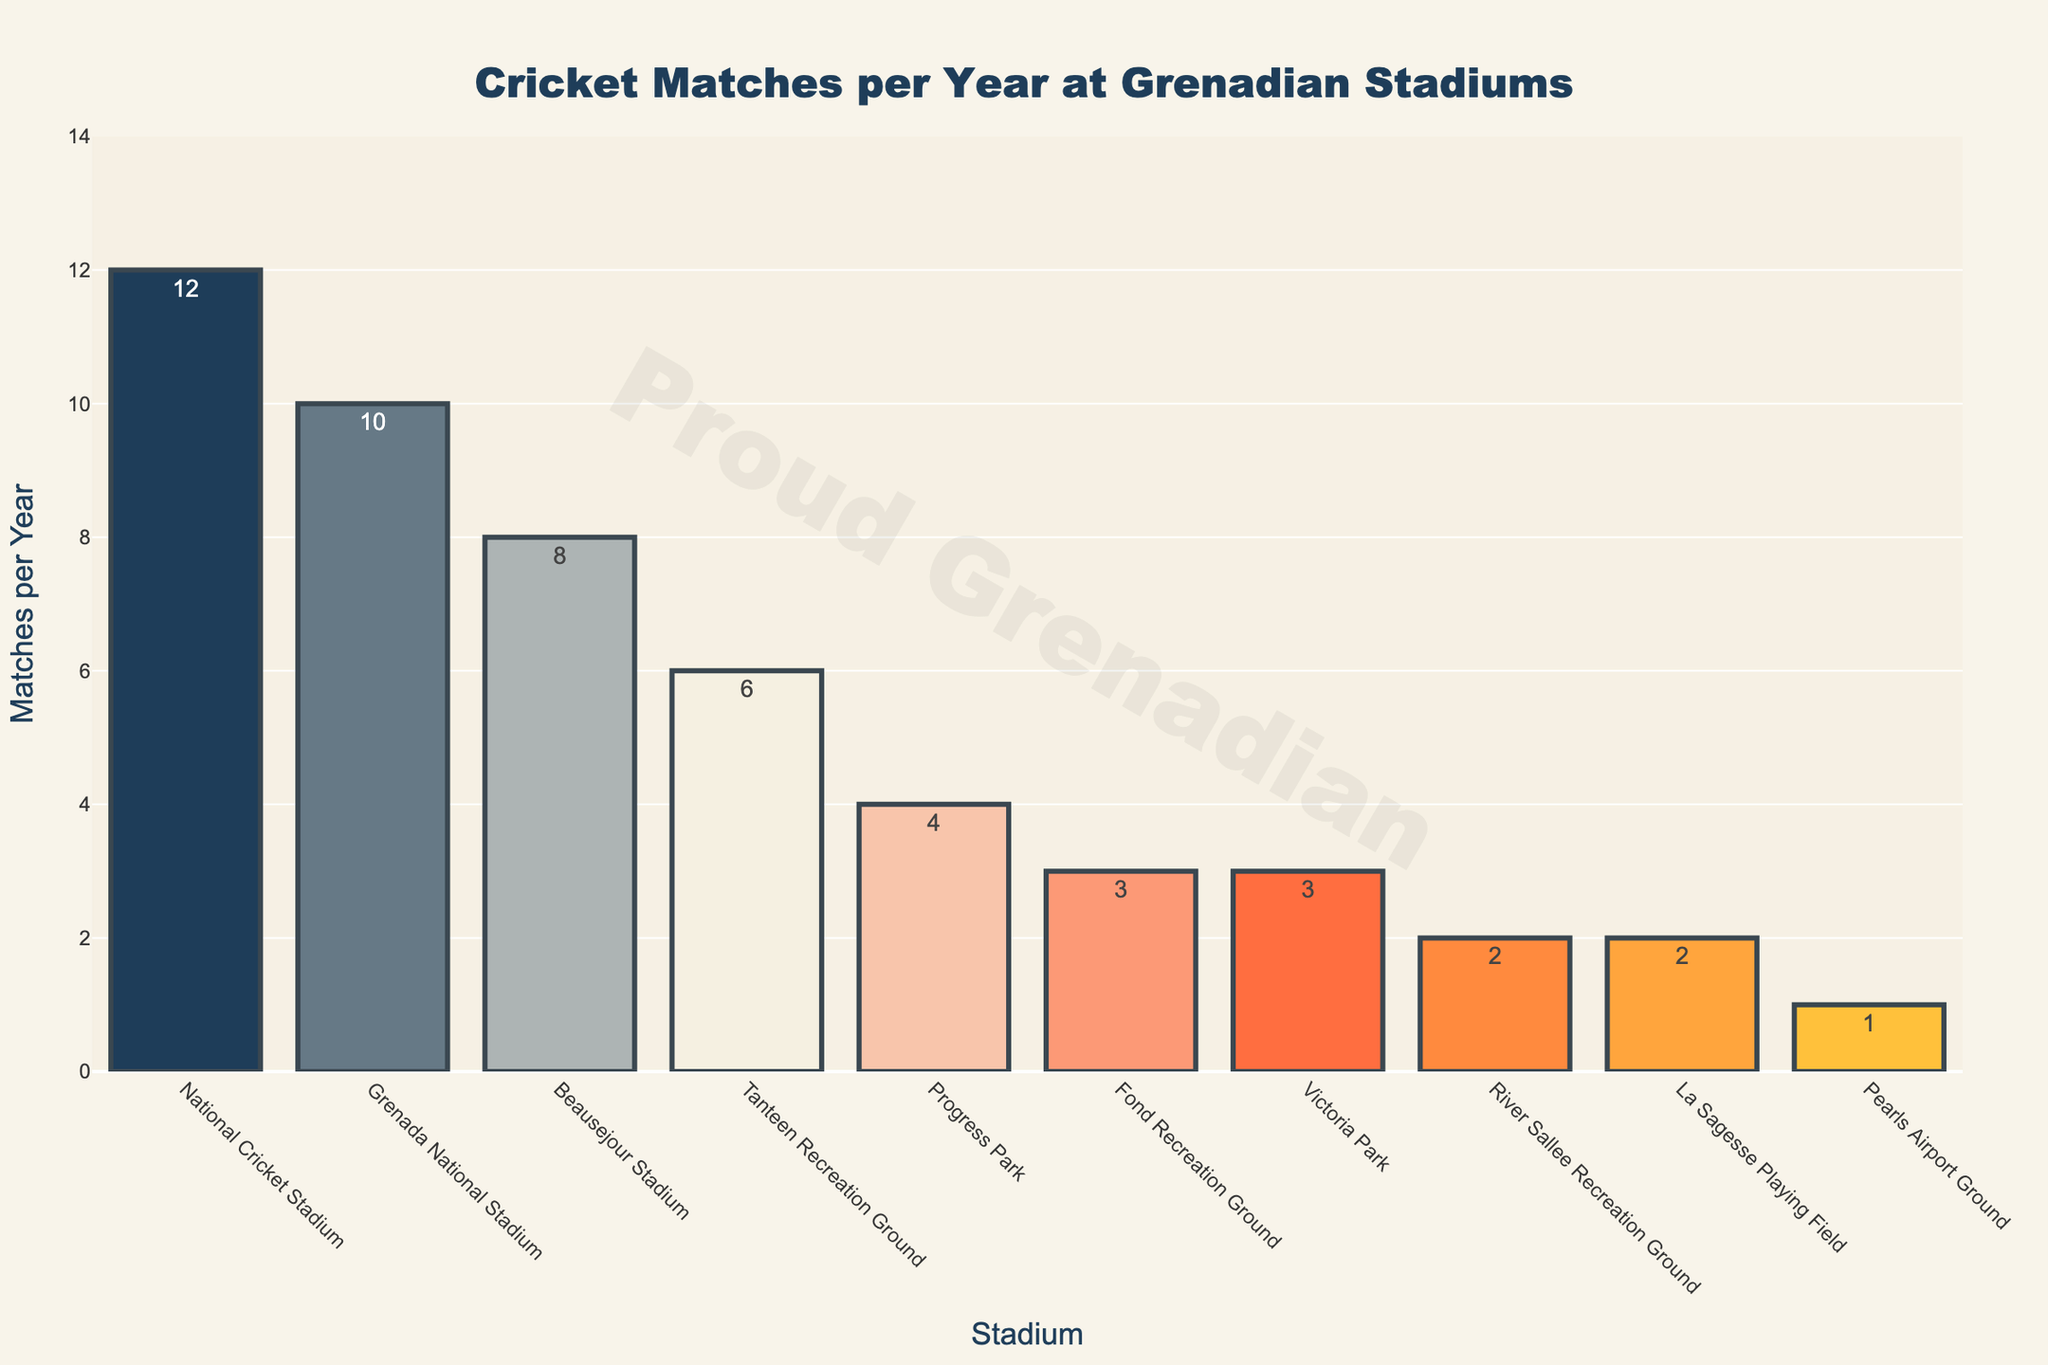Which stadium hosts the most cricket matches per year? The tallest bar in the bar chart represents the stadium with the highest number of matches per year.
Answer: National Cricket Stadium How many matches per year are held at Beausejour Stadium? Look for the bar labeled "Beausejour Stadium" and check the height and the text position displaying the number.
Answer: 8 Which stadium hosts fewer matches per year: Tanteen Recreation Ground or Grenada National Stadium? Compare the heights of the bars labeled "Tanteen Recreation Ground" and "Grenada National Stadium."
Answer: Tanteen Recreation Ground What is the total number of matches held at Progress Park and Fond Recreation Ground combined? Add the number of matches from Progress Park (4) and Fond Recreation Ground (3).
Answer: 7 What is the difference in the number of matches per year between the stadium hosting the most and the least number of matches? Subtract the number of matches at the stadium with the least matches (Pearls Airport Ground, 1) from the number of matches at the stadium with the most matches (National Cricket Stadium, 12).
Answer: 11 Which stadium has the second highest number of matches per year? Look for the second tallest bar in the chart.
Answer: Grenada National Stadium How many more matches per year are held at National Cricket Stadium compared to River Sallee Recreation Ground? Subtract the number of matches at River Sallee Recreation Ground (2) from the number of matches at National Cricket Stadium (12).
Answer: 10 In terms of cricket matches hosted per year, are there more stadiums with at least 5 matches or fewer than 5 matches? Count the number of bars representing 5 or more matches and those representing less than 5 matches.
Answer: Fewer than 5 matches What is the average number of matches held at all the stadiums combined? Sum the number of matches for all stadiums (51) and divide by the total number of stadiums (10).
Answer: 5.1 Which stadiums host the same number of matches per year? Look for bars that have equal heights and read their labels.
Answer: Fond Recreation Ground and Victoria Park; River Sallee Recreation Ground and La Sagesse Playing Field 